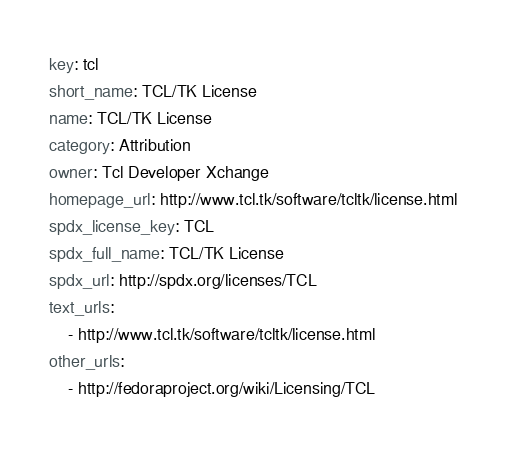Convert code to text. <code><loc_0><loc_0><loc_500><loc_500><_YAML_>key: tcl
short_name: TCL/TK License
name: TCL/TK License
category: Attribution
owner: Tcl Developer Xchange
homepage_url: http://www.tcl.tk/software/tcltk/license.html
spdx_license_key: TCL
spdx_full_name: TCL/TK License
spdx_url: http://spdx.org/licenses/TCL
text_urls:
    - http://www.tcl.tk/software/tcltk/license.html
other_urls:
    - http://fedoraproject.org/wiki/Licensing/TCL
</code> 